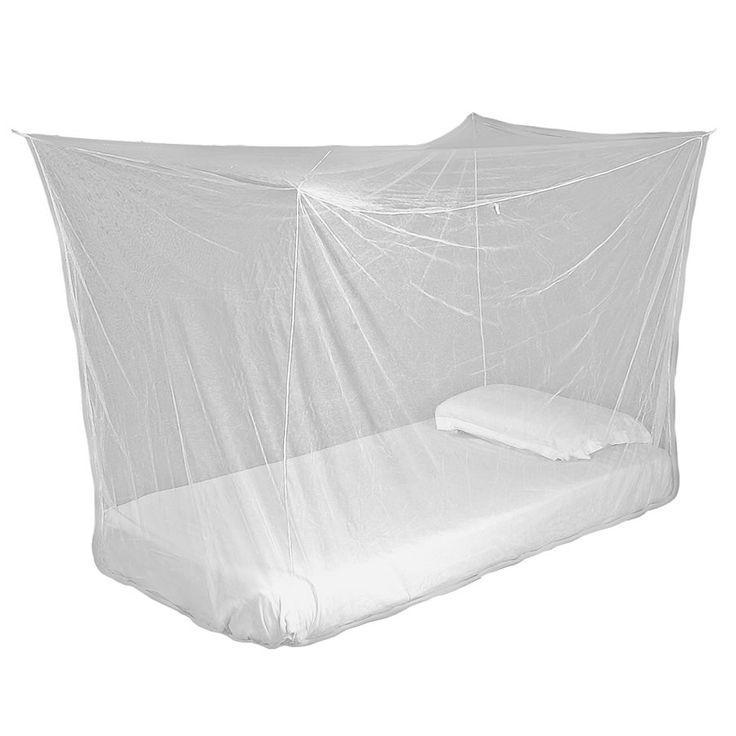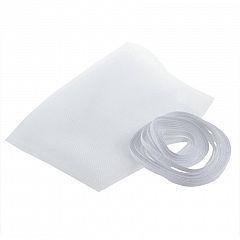The first image is the image on the left, the second image is the image on the right. For the images shown, is this caption "There is exactly one pillow on the bed in one of the images." true? Answer yes or no. Yes. 